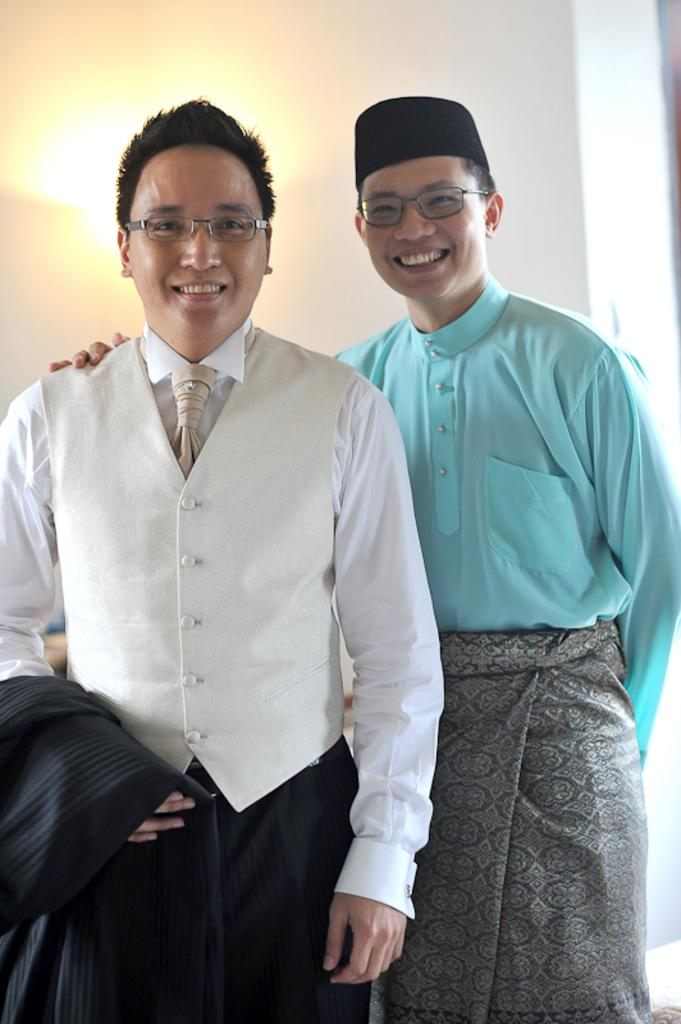How many people are in the image? There are two persons standing in the image. What is the facial expression of the persons in the image? The persons are smiling. What can be seen in the background of the image? There is a wall in the background of the image. What is attached to the wall in the image? There is a light on the wall. What type of silk fabric is draped over the persons' faces in the image? There is no silk fabric or any fabric covering the persons' faces in the image. 